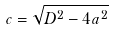Convert formula to latex. <formula><loc_0><loc_0><loc_500><loc_500>c = \sqrt { D ^ { 2 } - 4 a ^ { 2 } }</formula> 